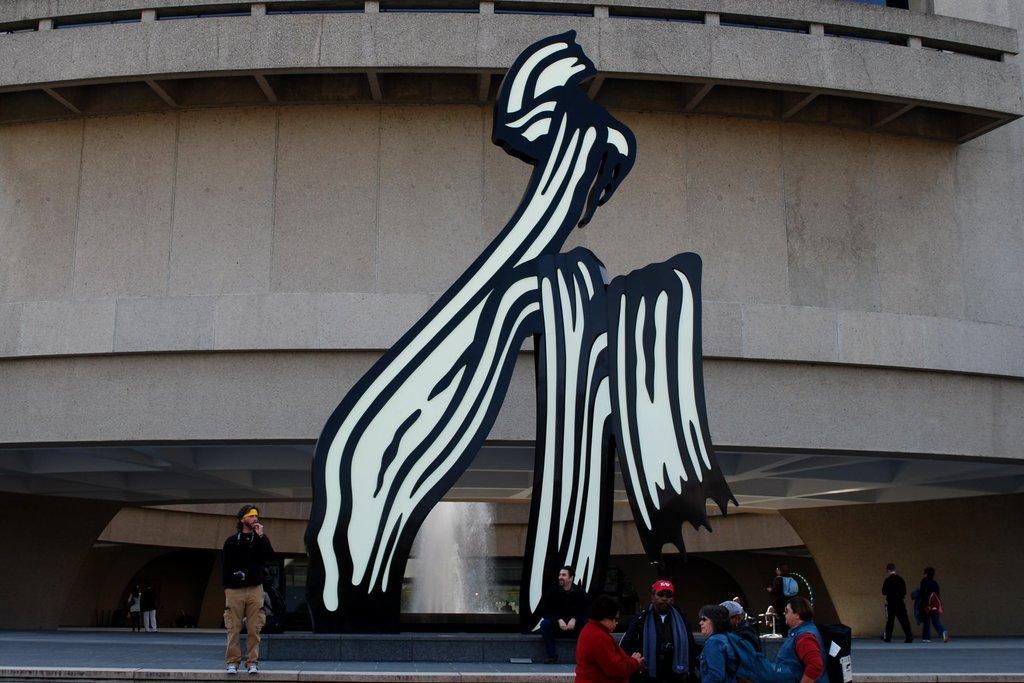Please provide a concise description of this image. In this image I can see an emblem like construction in the center of the image. I can see a fountain behind it. I can see a building, a few people standing, sitting and walking at the bottom of the image. 